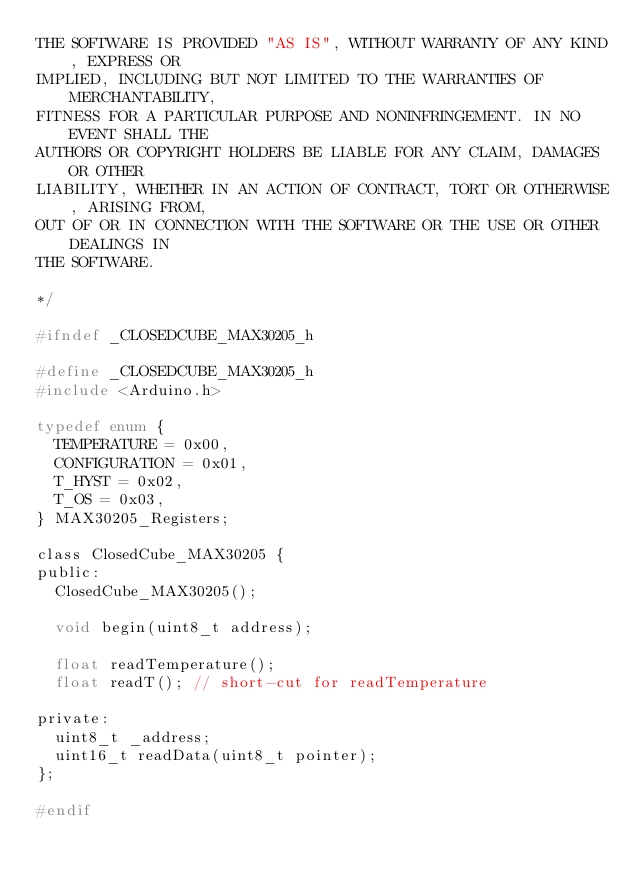Convert code to text. <code><loc_0><loc_0><loc_500><loc_500><_C_>THE SOFTWARE IS PROVIDED "AS IS", WITHOUT WARRANTY OF ANY KIND, EXPRESS OR
IMPLIED, INCLUDING BUT NOT LIMITED TO THE WARRANTIES OF MERCHANTABILITY,
FITNESS FOR A PARTICULAR PURPOSE AND NONINFRINGEMENT. IN NO EVENT SHALL THE
AUTHORS OR COPYRIGHT HOLDERS BE LIABLE FOR ANY CLAIM, DAMAGES OR OTHER
LIABILITY, WHETHER IN AN ACTION OF CONTRACT, TORT OR OTHERWISE, ARISING FROM,
OUT OF OR IN CONNECTION WITH THE SOFTWARE OR THE USE OR OTHER DEALINGS IN
THE SOFTWARE.

*/

#ifndef _CLOSEDCUBE_MAX30205_h

#define _CLOSEDCUBE_MAX30205_h
#include <Arduino.h>

typedef enum {
	TEMPERATURE = 0x00,
	CONFIGURATION = 0x01,
	T_HYST = 0x02,
	T_OS = 0x03,
} MAX30205_Registers;

class ClosedCube_MAX30205 {
public:
	ClosedCube_MAX30205();

	void begin(uint8_t address);

	float readTemperature();
	float readT(); // short-cut for readTemperature

private:
	uint8_t _address;
	uint16_t readData(uint8_t pointer);
};

#endif

</code> 